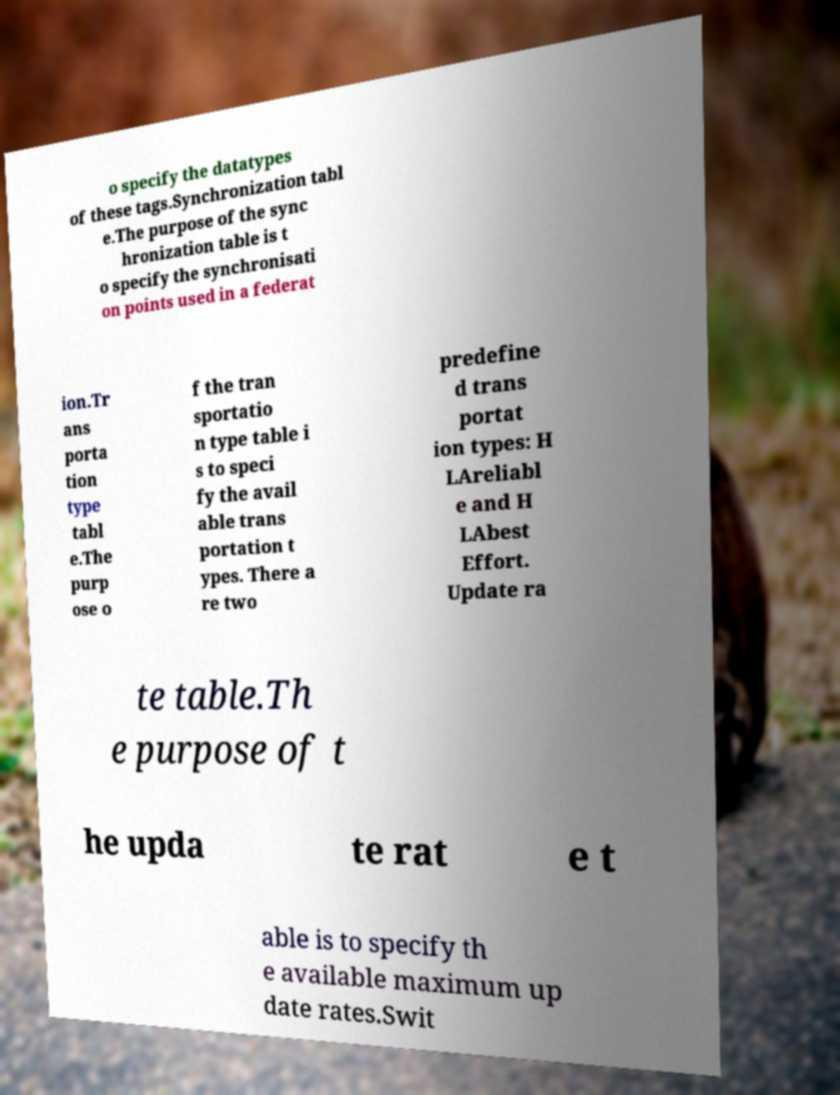Could you assist in decoding the text presented in this image and type it out clearly? o specify the datatypes of these tags.Synchronization tabl e.The purpose of the sync hronization table is t o specify the synchronisati on points used in a federat ion.Tr ans porta tion type tabl e.The purp ose o f the tran sportatio n type table i s to speci fy the avail able trans portation t ypes. There a re two predefine d trans portat ion types: H LAreliabl e and H LAbest Effort. Update ra te table.Th e purpose of t he upda te rat e t able is to specify th e available maximum up date rates.Swit 